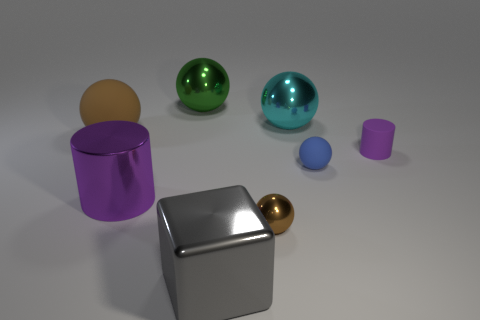Subtract all tiny matte spheres. How many spheres are left? 4 Subtract all blue spheres. How many spheres are left? 4 Subtract all purple spheres. Subtract all gray cubes. How many spheres are left? 5 Add 1 tiny matte objects. How many objects exist? 9 Subtract all cubes. How many objects are left? 7 Add 2 small rubber objects. How many small rubber objects exist? 4 Subtract 0 green blocks. How many objects are left? 8 Subtract all things. Subtract all large blue cylinders. How many objects are left? 0 Add 6 small blue matte balls. How many small blue matte balls are left? 7 